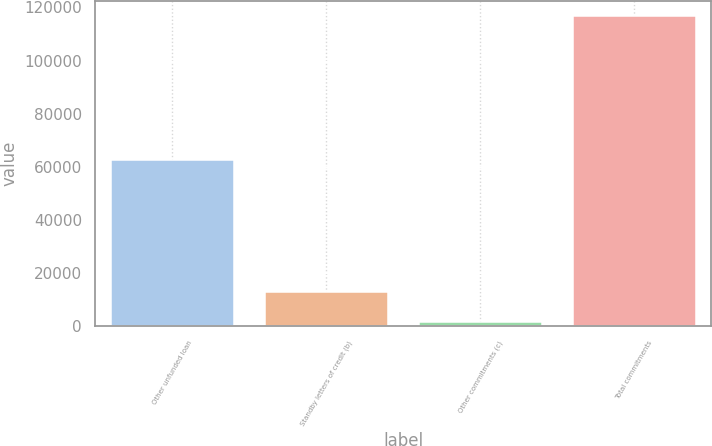Convert chart. <chart><loc_0><loc_0><loc_500><loc_500><bar_chart><fcel>Other unfunded loan<fcel>Standby letters of credit (b)<fcel>Other commitments (c)<fcel>Total commitments<nl><fcel>62665<fcel>12928.5<fcel>1408<fcel>116613<nl></chart> 